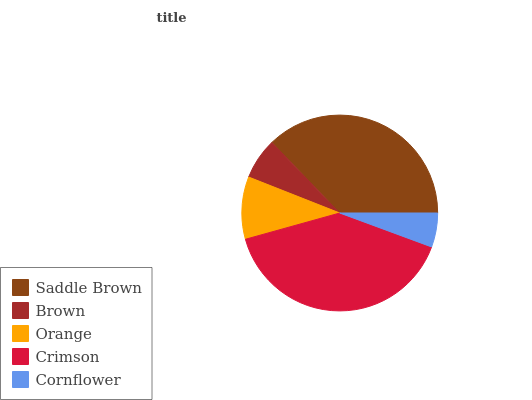Is Cornflower the minimum?
Answer yes or no. Yes. Is Crimson the maximum?
Answer yes or no. Yes. Is Brown the minimum?
Answer yes or no. No. Is Brown the maximum?
Answer yes or no. No. Is Saddle Brown greater than Brown?
Answer yes or no. Yes. Is Brown less than Saddle Brown?
Answer yes or no. Yes. Is Brown greater than Saddle Brown?
Answer yes or no. No. Is Saddle Brown less than Brown?
Answer yes or no. No. Is Orange the high median?
Answer yes or no. Yes. Is Orange the low median?
Answer yes or no. Yes. Is Crimson the high median?
Answer yes or no. No. Is Crimson the low median?
Answer yes or no. No. 